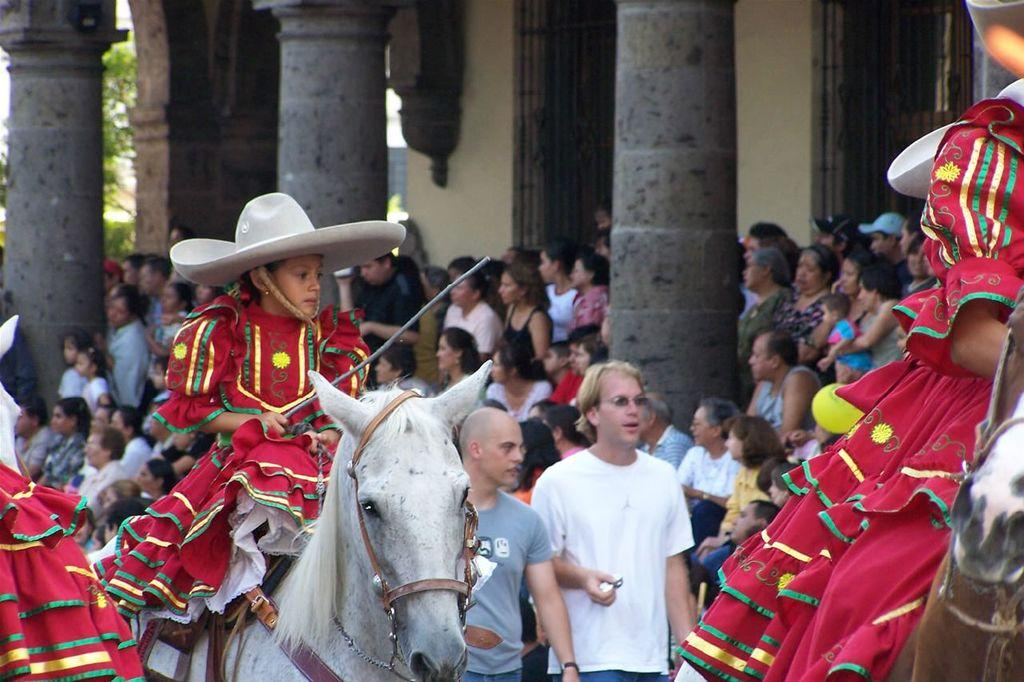What is the main subject of the image? There is a child in the image. What is the child doing in the image? The child is on a horse. What can be seen in the background of the image? There are people, pillars, and a wall in the background of the image. How many snakes are slithering around the child's feet in the image? There are no snakes present in the image; the child is on a horse. What type of rat can be seen climbing the pillar in the image? There is no rat present in the image; the background elements include people, pillars, and a wall. 